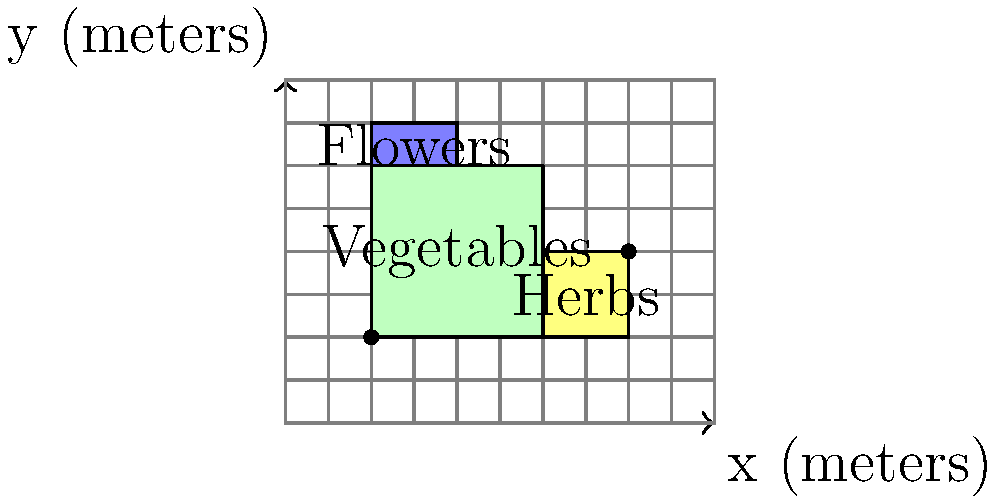As an AI programmer optimizing your lifestyle, you've decided to create a coordinate-based grid system for efficient garden planning in your small backyard. The grid is measured in meters, and you've divided the space into three sections: vegetables, herbs, and flowers. If the bottom-left corner of the vegetable section is at coordinates $(2,2)$ and the top-right corner of the herb section is at $(8,4)$, what is the total area in square meters of the vegetable and herb sections combined? To solve this problem, let's break it down into steps:

1. Identify the coordinates:
   - Vegetable section: bottom-left $(2,2)$, top-right $(6,6)$
   - Herb section: bottom-left $(6,2)$, top-right $(8,4)$

2. Calculate the area of the vegetable section:
   - Width = $6 - 2 = 4$ meters
   - Height = $6 - 2 = 4$ meters
   - Area of vegetables = $4 \times 4 = 16$ square meters

3. Calculate the area of the herb section:
   - Width = $8 - 6 = 2$ meters
   - Height = $4 - 2 = 2$ meters
   - Area of herbs = $2 \times 2 = 4$ square meters

4. Sum the areas:
   - Total area = Area of vegetables + Area of herbs
   - Total area = $16 + 4 = 20$ square meters

Therefore, the total area of the vegetable and herb sections combined is 20 square meters.
Answer: $20 \text{ m}^2$ 